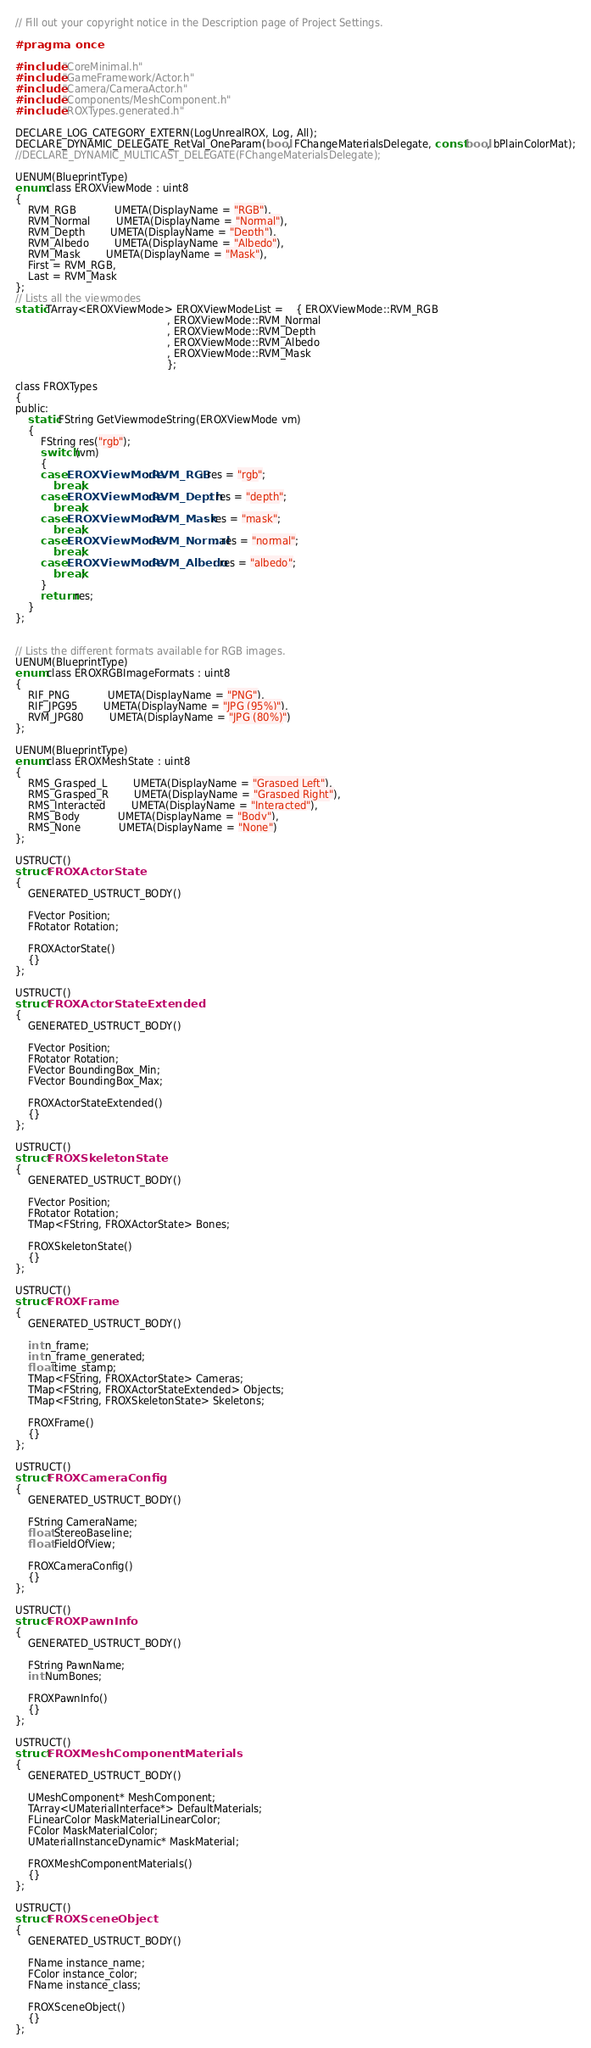<code> <loc_0><loc_0><loc_500><loc_500><_C_>// Fill out your copyright notice in the Description page of Project Settings.

#pragma once

#include "CoreMinimal.h"
#include "GameFramework/Actor.h"
#include "Camera/CameraActor.h"
#include "Components/MeshComponent.h"
#include "ROXTypes.generated.h"

DECLARE_LOG_CATEGORY_EXTERN(LogUnrealROX, Log, All);
DECLARE_DYNAMIC_DELEGATE_RetVal_OneParam(bool, FChangeMaterialsDelegate, const bool, bPlainColorMat);
//DECLARE_DYNAMIC_MULTICAST_DELEGATE(FChangeMaterialsDelegate);

UENUM(BlueprintType)
enum class EROXViewMode : uint8
{
	RVM_RGB			UMETA(DisplayName = "RGB"),
	RVM_Normal		UMETA(DisplayName = "Normal"),
	RVM_Depth		UMETA(DisplayName = "Depth"),
	RVM_Albedo		UMETA(DisplayName = "Albedo"),
	RVM_Mask		UMETA(DisplayName = "Mask"),
	First = RVM_RGB,
	Last = RVM_Mask
};
// Lists all the viewmodes
static TArray<EROXViewMode> EROXViewModeList =	{ EROXViewMode::RVM_RGB
												, EROXViewMode::RVM_Normal
												, EROXViewMode::RVM_Depth
												, EROXViewMode::RVM_Albedo
												, EROXViewMode::RVM_Mask
												};

class FROXTypes
{
public:
	static FString GetViewmodeString(EROXViewMode vm)
	{
		FString res("rgb");
		switch (vm)
		{
		case EROXViewMode::RVM_RGB: res = "rgb";
			break;
		case EROXViewMode::RVM_Depth: res = "depth";
			break;
		case EROXViewMode::RVM_Mask: res = "mask";
			break;
		case EROXViewMode::RVM_Normal: res = "normal";
			break;
		case EROXViewMode::RVM_Albedo: res = "albedo";
			break;
		}
		return res;
	}
};


// Lists the different formats available for RGB images.
UENUM(BlueprintType)
enum class EROXRGBImageFormats : uint8
{
	RIF_PNG			UMETA(DisplayName = "PNG"),
	RIF_JPG95		UMETA(DisplayName = "JPG (95%)"),
	RVM_JPG80		UMETA(DisplayName = "JPG (80%)")
};

UENUM(BlueprintType)
enum class EROXMeshState : uint8
{
	RMS_Grasped_L		UMETA(DisplayName = "Grasped Left"),
	RMS_Grasped_R		UMETA(DisplayName = "Grasped Right"),
	RMS_Interacted		UMETA(DisplayName = "Interacted"),
	RMS_Body			UMETA(DisplayName = "Body"),
	RMS_None			UMETA(DisplayName = "None")
};

USTRUCT()
struct FROXActorState
{
	GENERATED_USTRUCT_BODY()

	FVector Position;
	FRotator Rotation;

	FROXActorState()
	{}
};

USTRUCT()
struct FROXActorStateExtended
{
	GENERATED_USTRUCT_BODY()

	FVector Position;
	FRotator Rotation;
	FVector BoundingBox_Min;
	FVector BoundingBox_Max;

	FROXActorStateExtended()
	{}
};

USTRUCT()
struct FROXSkeletonState
{
	GENERATED_USTRUCT_BODY()

	FVector Position;
	FRotator Rotation;
	TMap<FString, FROXActorState> Bones;

	FROXSkeletonState()
	{}
};

USTRUCT()
struct FROXFrame
{
	GENERATED_USTRUCT_BODY()

	int n_frame;
	int n_frame_generated;
	float time_stamp;
	TMap<FString, FROXActorState> Cameras;
	TMap<FString, FROXActorStateExtended> Objects;
	TMap<FString, FROXSkeletonState> Skeletons;

	FROXFrame()
	{}
};

USTRUCT()
struct FROXCameraConfig
{
	GENERATED_USTRUCT_BODY()

	FString CameraName;
	float StereoBaseline;
	float FieldOfView;

	FROXCameraConfig()
	{}
};

USTRUCT()
struct FROXPawnInfo
{
	GENERATED_USTRUCT_BODY()

	FString PawnName;
	int NumBones;

	FROXPawnInfo()
	{}
};

USTRUCT()
struct FROXMeshComponentMaterials
{
	GENERATED_USTRUCT_BODY()

	UMeshComponent* MeshComponent;
	TArray<UMaterialInterface*> DefaultMaterials;
	FLinearColor MaskMaterialLinearColor;
	FColor MaskMaterialColor;
	UMaterialInstanceDynamic* MaskMaterial;

	FROXMeshComponentMaterials()
	{}
};

USTRUCT()
struct FROXSceneObject
{
	GENERATED_USTRUCT_BODY()

	FName instance_name;
	FColor instance_color;
	FName instance_class;

	FROXSceneObject()
	{}
};
</code> 